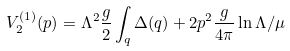<formula> <loc_0><loc_0><loc_500><loc_500>\ V _ { 2 } ^ { ( 1 ) } ( p ) = \Lambda ^ { 2 } \frac { g } { 2 } \int _ { q } \Delta ( q ) + 2 p ^ { 2 } \frac { g } { 4 \pi } \ln \Lambda / \mu</formula> 